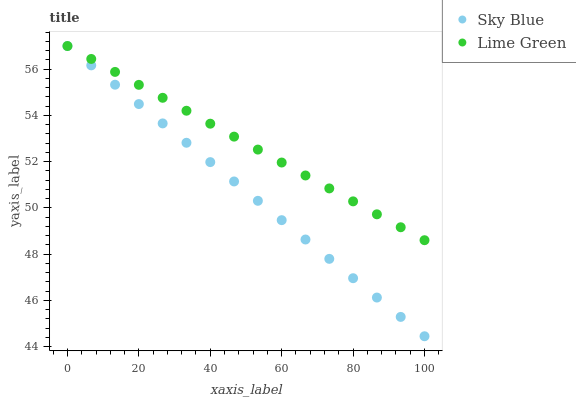Does Sky Blue have the minimum area under the curve?
Answer yes or no. Yes. Does Lime Green have the maximum area under the curve?
Answer yes or no. Yes. Does Lime Green have the minimum area under the curve?
Answer yes or no. No. Is Lime Green the smoothest?
Answer yes or no. Yes. Is Sky Blue the roughest?
Answer yes or no. Yes. Is Lime Green the roughest?
Answer yes or no. No. Does Sky Blue have the lowest value?
Answer yes or no. Yes. Does Lime Green have the lowest value?
Answer yes or no. No. Does Lime Green have the highest value?
Answer yes or no. Yes. Does Sky Blue intersect Lime Green?
Answer yes or no. Yes. Is Sky Blue less than Lime Green?
Answer yes or no. No. Is Sky Blue greater than Lime Green?
Answer yes or no. No. 